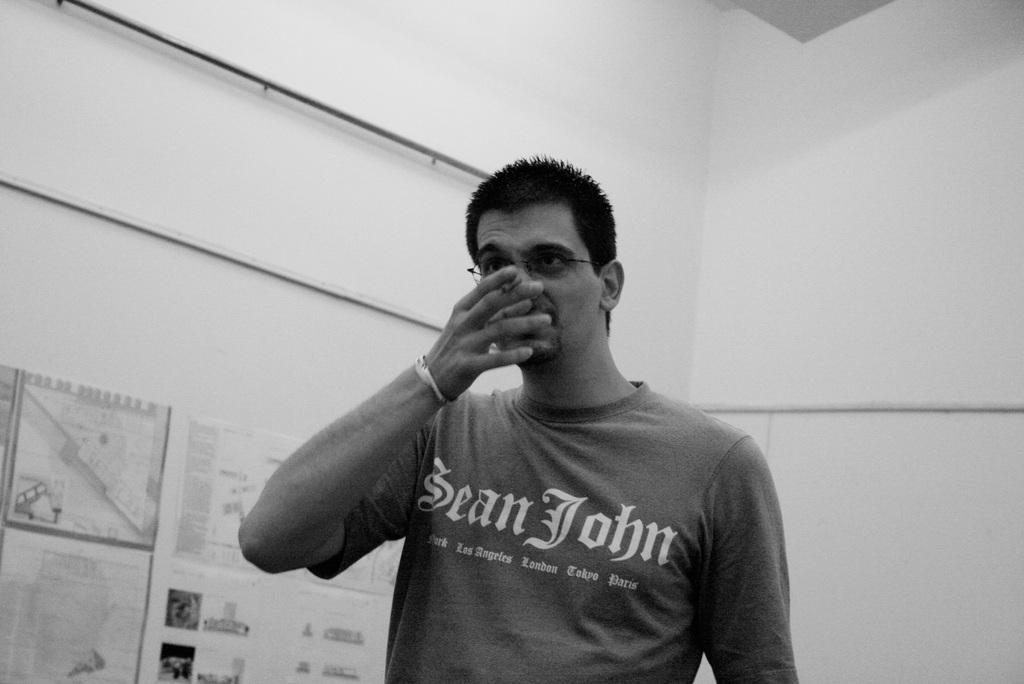What is the person in the image wearing? The person in the image is wearing a dress. What can be seen on the left side of the image? There are papers attached to the wall on the left side of the image. What color scheme is used in the image? The image is black and white. What type of clouds can be seen in the image? There are no clouds visible in the image, as it is black and white and does not depict an outdoor scene. 